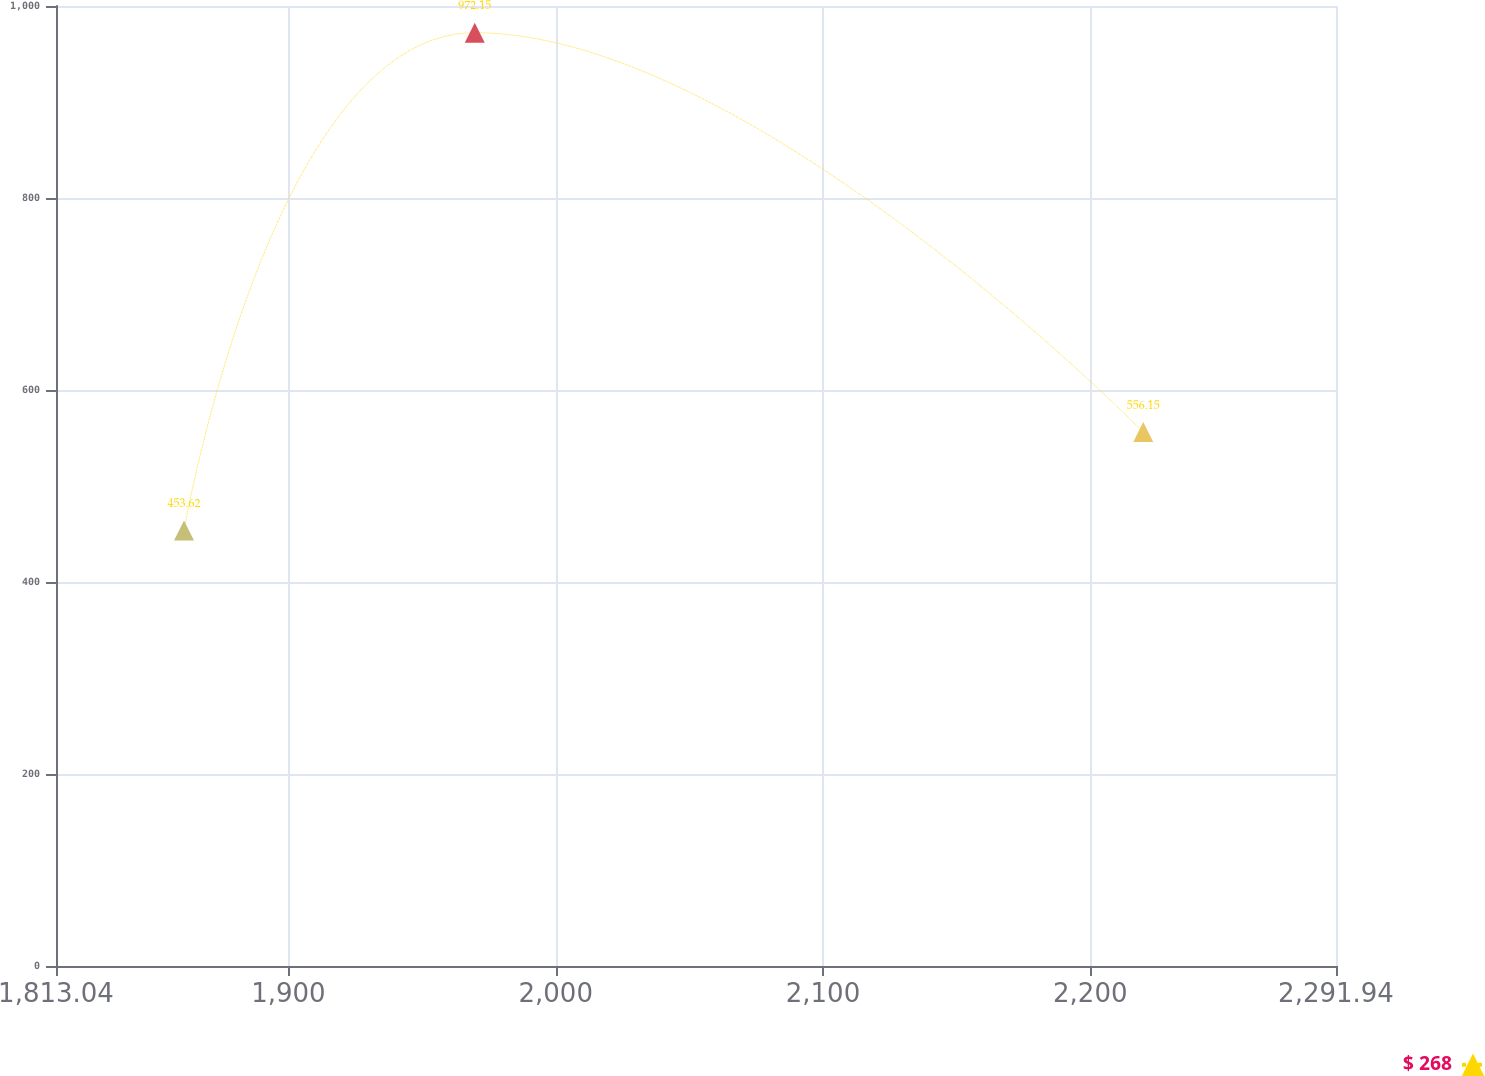<chart> <loc_0><loc_0><loc_500><loc_500><line_chart><ecel><fcel>$ 268<nl><fcel>1860.93<fcel>453.62<nl><fcel>1969.71<fcel>972.15<nl><fcel>2219.83<fcel>556.15<nl><fcel>2339.83<fcel>127.45<nl></chart> 